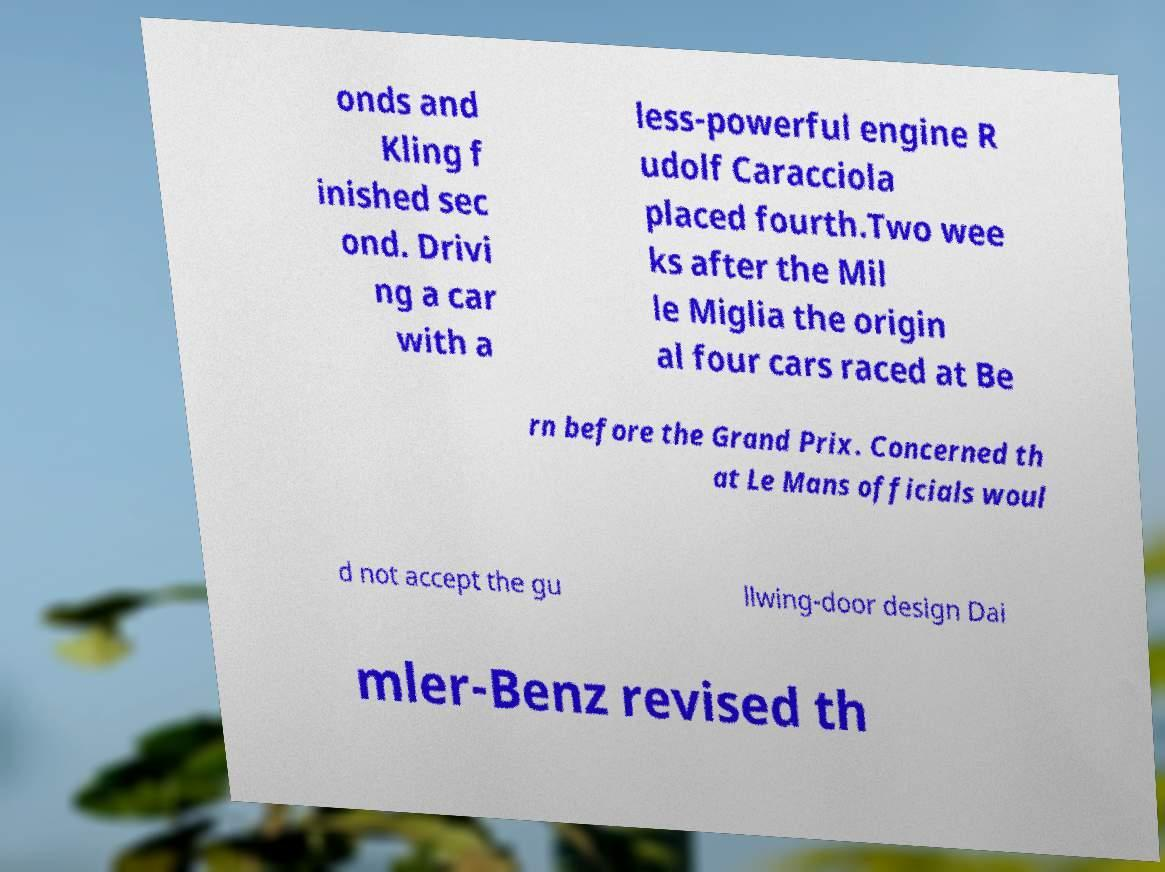For documentation purposes, I need the text within this image transcribed. Could you provide that? onds and Kling f inished sec ond. Drivi ng a car with a less-powerful engine R udolf Caracciola placed fourth.Two wee ks after the Mil le Miglia the origin al four cars raced at Be rn before the Grand Prix. Concerned th at Le Mans officials woul d not accept the gu llwing-door design Dai mler-Benz revised th 